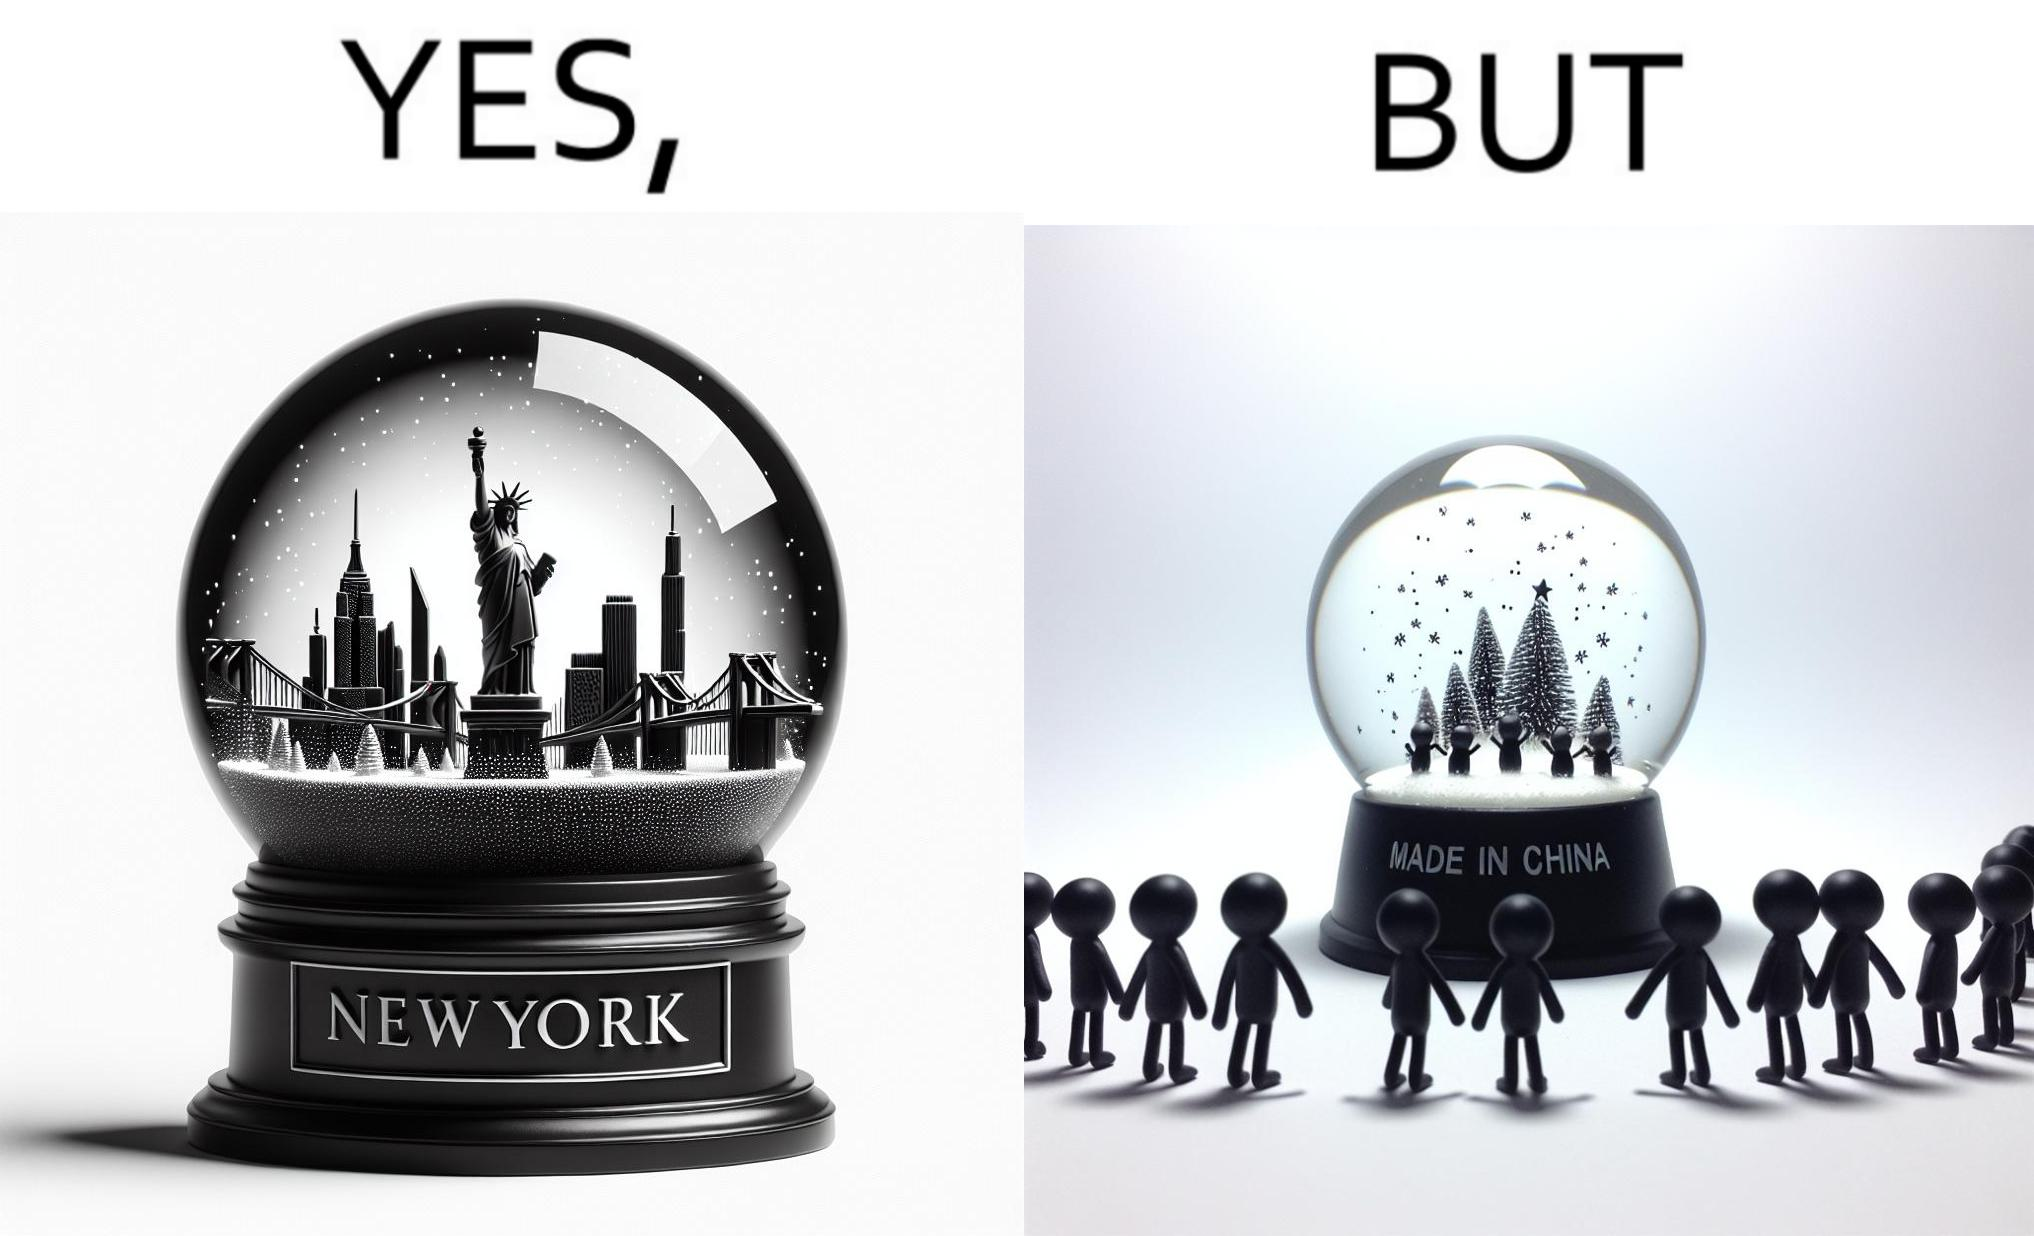Describe the content of this image. The image is ironic because the snowglobe says 'New York' while it is made in China 